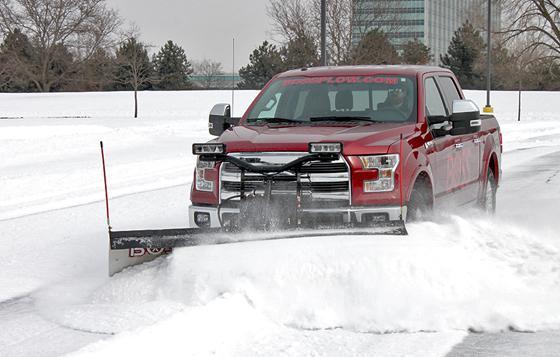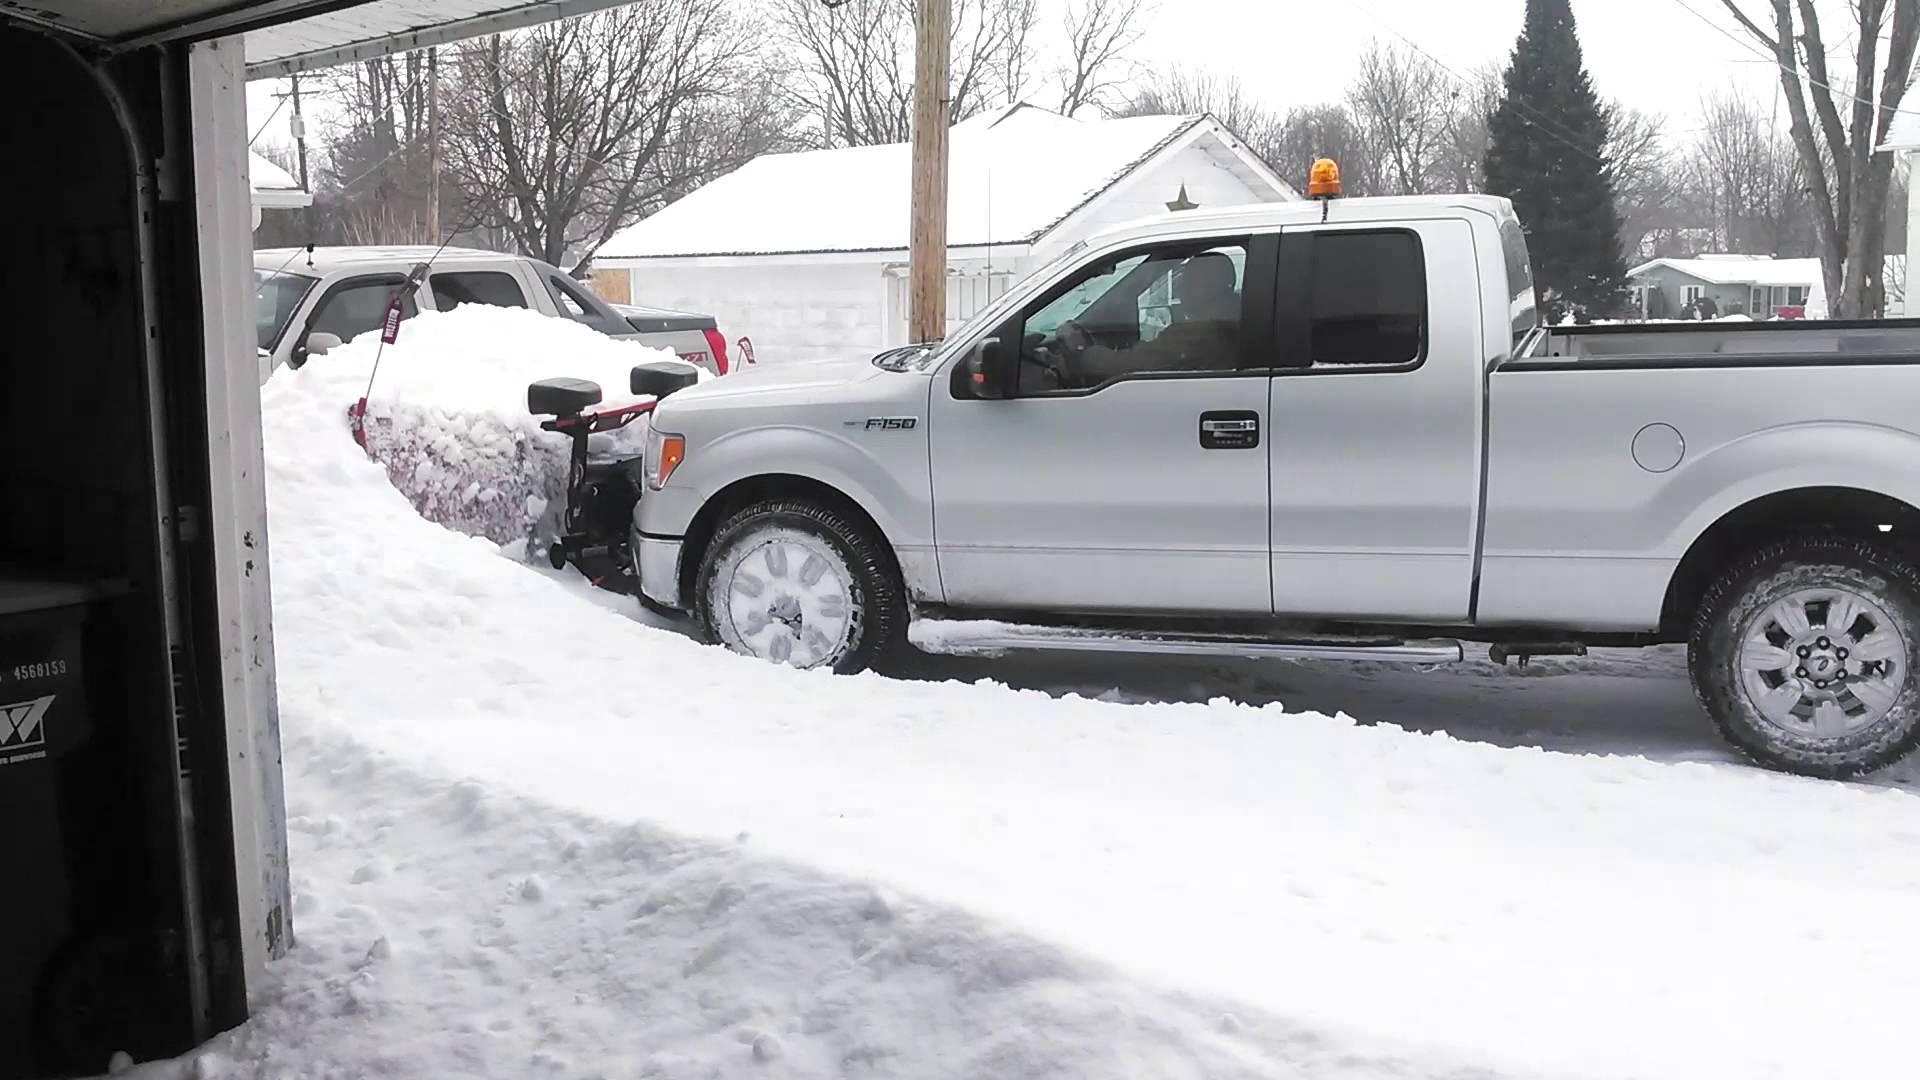The first image is the image on the left, the second image is the image on the right. For the images shown, is this caption "A red truck pushes a plow through the snow in each of the images." true? Answer yes or no. No. The first image is the image on the left, the second image is the image on the right. Examine the images to the left and right. Is the description "One image shows a non-red pickup truck pushing a large mound of snow with a plow." accurate? Answer yes or no. Yes. 